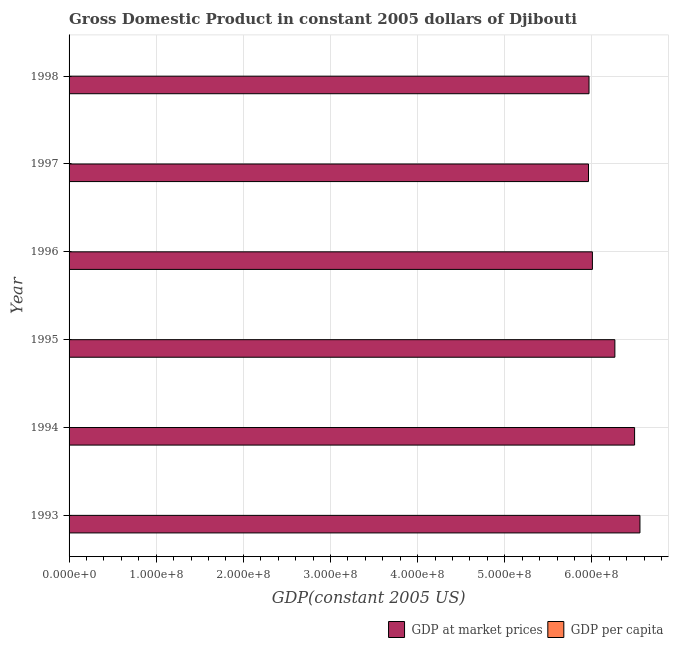How many different coloured bars are there?
Keep it short and to the point. 2. How many groups of bars are there?
Offer a very short reply. 6. Are the number of bars on each tick of the Y-axis equal?
Offer a terse response. Yes. How many bars are there on the 3rd tick from the top?
Provide a short and direct response. 2. What is the label of the 3rd group of bars from the top?
Offer a terse response. 1996. What is the gdp at market prices in 1998?
Make the answer very short. 5.97e+08. Across all years, what is the maximum gdp per capita?
Provide a succinct answer. 1024.76. Across all years, what is the minimum gdp per capita?
Give a very brief answer. 854.42. In which year was the gdp at market prices maximum?
Offer a very short reply. 1993. In which year was the gdp per capita minimum?
Give a very brief answer. 1998. What is the total gdp at market prices in the graph?
Your response must be concise. 3.72e+09. What is the difference between the gdp per capita in 1994 and that in 1997?
Provide a short and direct response. 129.22. What is the difference between the gdp at market prices in 1998 and the gdp per capita in 1994?
Your response must be concise. 5.97e+08. What is the average gdp at market prices per year?
Give a very brief answer. 6.21e+08. In the year 1995, what is the difference between the gdp per capita and gdp at market prices?
Offer a very short reply. -6.26e+08. What is the ratio of the gdp at market prices in 1994 to that in 1995?
Provide a short and direct response. 1.04. Is the gdp at market prices in 1994 less than that in 1998?
Your answer should be very brief. No. Is the difference between the gdp per capita in 1995 and 1997 greater than the difference between the gdp at market prices in 1995 and 1997?
Ensure brevity in your answer.  No. What is the difference between the highest and the second highest gdp per capita?
Your answer should be compact. 26.26. What is the difference between the highest and the lowest gdp at market prices?
Your response must be concise. 5.90e+07. What does the 2nd bar from the top in 1998 represents?
Your answer should be compact. GDP at market prices. What does the 2nd bar from the bottom in 1996 represents?
Give a very brief answer. GDP per capita. How many bars are there?
Your answer should be very brief. 12. Are all the bars in the graph horizontal?
Make the answer very short. Yes. What is the difference between two consecutive major ticks on the X-axis?
Provide a short and direct response. 1.00e+08. Does the graph contain any zero values?
Make the answer very short. No. Where does the legend appear in the graph?
Give a very brief answer. Bottom right. How many legend labels are there?
Offer a very short reply. 2. How are the legend labels stacked?
Your answer should be very brief. Horizontal. What is the title of the graph?
Provide a succinct answer. Gross Domestic Product in constant 2005 dollars of Djibouti. Does "Urban Population" appear as one of the legend labels in the graph?
Offer a very short reply. No. What is the label or title of the X-axis?
Make the answer very short. GDP(constant 2005 US). What is the GDP(constant 2005 US) in GDP at market prices in 1993?
Provide a succinct answer. 6.55e+08. What is the GDP(constant 2005 US) of GDP per capita in 1993?
Give a very brief answer. 1024.76. What is the GDP(constant 2005 US) in GDP at market prices in 1994?
Give a very brief answer. 6.49e+08. What is the GDP(constant 2005 US) of GDP per capita in 1994?
Ensure brevity in your answer.  998.5. What is the GDP(constant 2005 US) in GDP at market prices in 1995?
Keep it short and to the point. 6.26e+08. What is the GDP(constant 2005 US) in GDP per capita in 1995?
Keep it short and to the point. 947.34. What is the GDP(constant 2005 US) in GDP at market prices in 1996?
Ensure brevity in your answer.  6.00e+08. What is the GDP(constant 2005 US) of GDP per capita in 1996?
Provide a short and direct response. 891.99. What is the GDP(constant 2005 US) in GDP at market prices in 1997?
Your answer should be very brief. 5.96e+08. What is the GDP(constant 2005 US) of GDP per capita in 1997?
Ensure brevity in your answer.  869.27. What is the GDP(constant 2005 US) of GDP at market prices in 1998?
Your answer should be compact. 5.97e+08. What is the GDP(constant 2005 US) in GDP per capita in 1998?
Offer a terse response. 854.42. Across all years, what is the maximum GDP(constant 2005 US) in GDP at market prices?
Your answer should be compact. 6.55e+08. Across all years, what is the maximum GDP(constant 2005 US) of GDP per capita?
Provide a short and direct response. 1024.76. Across all years, what is the minimum GDP(constant 2005 US) in GDP at market prices?
Keep it short and to the point. 5.96e+08. Across all years, what is the minimum GDP(constant 2005 US) of GDP per capita?
Your answer should be very brief. 854.42. What is the total GDP(constant 2005 US) in GDP at market prices in the graph?
Provide a short and direct response. 3.72e+09. What is the total GDP(constant 2005 US) of GDP per capita in the graph?
Provide a succinct answer. 5586.29. What is the difference between the GDP(constant 2005 US) of GDP at market prices in 1993 and that in 1994?
Your answer should be compact. 6.14e+06. What is the difference between the GDP(constant 2005 US) in GDP per capita in 1993 and that in 1994?
Offer a terse response. 26.26. What is the difference between the GDP(constant 2005 US) of GDP at market prices in 1993 and that in 1995?
Ensure brevity in your answer.  2.88e+07. What is the difference between the GDP(constant 2005 US) of GDP per capita in 1993 and that in 1995?
Provide a short and direct response. 77.42. What is the difference between the GDP(constant 2005 US) of GDP at market prices in 1993 and that in 1996?
Your response must be concise. 5.45e+07. What is the difference between the GDP(constant 2005 US) in GDP per capita in 1993 and that in 1996?
Provide a short and direct response. 132.77. What is the difference between the GDP(constant 2005 US) in GDP at market prices in 1993 and that in 1997?
Give a very brief answer. 5.90e+07. What is the difference between the GDP(constant 2005 US) in GDP per capita in 1993 and that in 1997?
Your response must be concise. 155.48. What is the difference between the GDP(constant 2005 US) in GDP at market prices in 1993 and that in 1998?
Give a very brief answer. 5.84e+07. What is the difference between the GDP(constant 2005 US) in GDP per capita in 1993 and that in 1998?
Offer a very short reply. 170.34. What is the difference between the GDP(constant 2005 US) in GDP at market prices in 1994 and that in 1995?
Your answer should be very brief. 2.26e+07. What is the difference between the GDP(constant 2005 US) of GDP per capita in 1994 and that in 1995?
Offer a very short reply. 51.15. What is the difference between the GDP(constant 2005 US) in GDP at market prices in 1994 and that in 1996?
Your response must be concise. 4.84e+07. What is the difference between the GDP(constant 2005 US) of GDP per capita in 1994 and that in 1996?
Offer a terse response. 106.5. What is the difference between the GDP(constant 2005 US) of GDP at market prices in 1994 and that in 1997?
Give a very brief answer. 5.29e+07. What is the difference between the GDP(constant 2005 US) of GDP per capita in 1994 and that in 1997?
Offer a very short reply. 129.22. What is the difference between the GDP(constant 2005 US) of GDP at market prices in 1994 and that in 1998?
Keep it short and to the point. 5.23e+07. What is the difference between the GDP(constant 2005 US) in GDP per capita in 1994 and that in 1998?
Your answer should be compact. 144.07. What is the difference between the GDP(constant 2005 US) in GDP at market prices in 1995 and that in 1996?
Offer a very short reply. 2.58e+07. What is the difference between the GDP(constant 2005 US) in GDP per capita in 1995 and that in 1996?
Offer a terse response. 55.35. What is the difference between the GDP(constant 2005 US) in GDP at market prices in 1995 and that in 1997?
Your answer should be very brief. 3.03e+07. What is the difference between the GDP(constant 2005 US) of GDP per capita in 1995 and that in 1997?
Give a very brief answer. 78.07. What is the difference between the GDP(constant 2005 US) in GDP at market prices in 1995 and that in 1998?
Ensure brevity in your answer.  2.97e+07. What is the difference between the GDP(constant 2005 US) in GDP per capita in 1995 and that in 1998?
Offer a very short reply. 92.92. What is the difference between the GDP(constant 2005 US) in GDP at market prices in 1996 and that in 1997?
Offer a very short reply. 4.48e+06. What is the difference between the GDP(constant 2005 US) of GDP per capita in 1996 and that in 1997?
Your response must be concise. 22.72. What is the difference between the GDP(constant 2005 US) of GDP at market prices in 1996 and that in 1998?
Your answer should be compact. 3.89e+06. What is the difference between the GDP(constant 2005 US) of GDP per capita in 1996 and that in 1998?
Ensure brevity in your answer.  37.57. What is the difference between the GDP(constant 2005 US) in GDP at market prices in 1997 and that in 1998?
Provide a succinct answer. -5.92e+05. What is the difference between the GDP(constant 2005 US) in GDP per capita in 1997 and that in 1998?
Keep it short and to the point. 14.85. What is the difference between the GDP(constant 2005 US) of GDP at market prices in 1993 and the GDP(constant 2005 US) of GDP per capita in 1994?
Your answer should be very brief. 6.55e+08. What is the difference between the GDP(constant 2005 US) of GDP at market prices in 1993 and the GDP(constant 2005 US) of GDP per capita in 1995?
Provide a succinct answer. 6.55e+08. What is the difference between the GDP(constant 2005 US) of GDP at market prices in 1993 and the GDP(constant 2005 US) of GDP per capita in 1996?
Your response must be concise. 6.55e+08. What is the difference between the GDP(constant 2005 US) of GDP at market prices in 1993 and the GDP(constant 2005 US) of GDP per capita in 1997?
Your response must be concise. 6.55e+08. What is the difference between the GDP(constant 2005 US) in GDP at market prices in 1993 and the GDP(constant 2005 US) in GDP per capita in 1998?
Your answer should be compact. 6.55e+08. What is the difference between the GDP(constant 2005 US) in GDP at market prices in 1994 and the GDP(constant 2005 US) in GDP per capita in 1995?
Give a very brief answer. 6.49e+08. What is the difference between the GDP(constant 2005 US) in GDP at market prices in 1994 and the GDP(constant 2005 US) in GDP per capita in 1996?
Keep it short and to the point. 6.49e+08. What is the difference between the GDP(constant 2005 US) in GDP at market prices in 1994 and the GDP(constant 2005 US) in GDP per capita in 1997?
Offer a very short reply. 6.49e+08. What is the difference between the GDP(constant 2005 US) in GDP at market prices in 1994 and the GDP(constant 2005 US) in GDP per capita in 1998?
Make the answer very short. 6.49e+08. What is the difference between the GDP(constant 2005 US) of GDP at market prices in 1995 and the GDP(constant 2005 US) of GDP per capita in 1996?
Provide a short and direct response. 6.26e+08. What is the difference between the GDP(constant 2005 US) in GDP at market prices in 1995 and the GDP(constant 2005 US) in GDP per capita in 1997?
Give a very brief answer. 6.26e+08. What is the difference between the GDP(constant 2005 US) in GDP at market prices in 1995 and the GDP(constant 2005 US) in GDP per capita in 1998?
Offer a very short reply. 6.26e+08. What is the difference between the GDP(constant 2005 US) of GDP at market prices in 1996 and the GDP(constant 2005 US) of GDP per capita in 1997?
Give a very brief answer. 6.00e+08. What is the difference between the GDP(constant 2005 US) in GDP at market prices in 1996 and the GDP(constant 2005 US) in GDP per capita in 1998?
Give a very brief answer. 6.00e+08. What is the difference between the GDP(constant 2005 US) in GDP at market prices in 1997 and the GDP(constant 2005 US) in GDP per capita in 1998?
Offer a terse response. 5.96e+08. What is the average GDP(constant 2005 US) in GDP at market prices per year?
Offer a terse response. 6.21e+08. What is the average GDP(constant 2005 US) of GDP per capita per year?
Provide a short and direct response. 931.05. In the year 1993, what is the difference between the GDP(constant 2005 US) in GDP at market prices and GDP(constant 2005 US) in GDP per capita?
Provide a short and direct response. 6.55e+08. In the year 1994, what is the difference between the GDP(constant 2005 US) of GDP at market prices and GDP(constant 2005 US) of GDP per capita?
Ensure brevity in your answer.  6.49e+08. In the year 1995, what is the difference between the GDP(constant 2005 US) of GDP at market prices and GDP(constant 2005 US) of GDP per capita?
Your answer should be very brief. 6.26e+08. In the year 1996, what is the difference between the GDP(constant 2005 US) in GDP at market prices and GDP(constant 2005 US) in GDP per capita?
Provide a short and direct response. 6.00e+08. In the year 1997, what is the difference between the GDP(constant 2005 US) in GDP at market prices and GDP(constant 2005 US) in GDP per capita?
Offer a very short reply. 5.96e+08. In the year 1998, what is the difference between the GDP(constant 2005 US) of GDP at market prices and GDP(constant 2005 US) of GDP per capita?
Provide a succinct answer. 5.97e+08. What is the ratio of the GDP(constant 2005 US) in GDP at market prices in 1993 to that in 1994?
Offer a terse response. 1.01. What is the ratio of the GDP(constant 2005 US) in GDP per capita in 1993 to that in 1994?
Keep it short and to the point. 1.03. What is the ratio of the GDP(constant 2005 US) in GDP at market prices in 1993 to that in 1995?
Make the answer very short. 1.05. What is the ratio of the GDP(constant 2005 US) in GDP per capita in 1993 to that in 1995?
Give a very brief answer. 1.08. What is the ratio of the GDP(constant 2005 US) in GDP at market prices in 1993 to that in 1996?
Your response must be concise. 1.09. What is the ratio of the GDP(constant 2005 US) in GDP per capita in 1993 to that in 1996?
Provide a succinct answer. 1.15. What is the ratio of the GDP(constant 2005 US) of GDP at market prices in 1993 to that in 1997?
Ensure brevity in your answer.  1.1. What is the ratio of the GDP(constant 2005 US) in GDP per capita in 1993 to that in 1997?
Give a very brief answer. 1.18. What is the ratio of the GDP(constant 2005 US) in GDP at market prices in 1993 to that in 1998?
Make the answer very short. 1.1. What is the ratio of the GDP(constant 2005 US) of GDP per capita in 1993 to that in 1998?
Your answer should be very brief. 1.2. What is the ratio of the GDP(constant 2005 US) in GDP at market prices in 1994 to that in 1995?
Your answer should be compact. 1.04. What is the ratio of the GDP(constant 2005 US) of GDP per capita in 1994 to that in 1995?
Offer a terse response. 1.05. What is the ratio of the GDP(constant 2005 US) in GDP at market prices in 1994 to that in 1996?
Your response must be concise. 1.08. What is the ratio of the GDP(constant 2005 US) of GDP per capita in 1994 to that in 1996?
Keep it short and to the point. 1.12. What is the ratio of the GDP(constant 2005 US) in GDP at market prices in 1994 to that in 1997?
Ensure brevity in your answer.  1.09. What is the ratio of the GDP(constant 2005 US) of GDP per capita in 1994 to that in 1997?
Provide a succinct answer. 1.15. What is the ratio of the GDP(constant 2005 US) in GDP at market prices in 1994 to that in 1998?
Make the answer very short. 1.09. What is the ratio of the GDP(constant 2005 US) in GDP per capita in 1994 to that in 1998?
Provide a succinct answer. 1.17. What is the ratio of the GDP(constant 2005 US) of GDP at market prices in 1995 to that in 1996?
Your answer should be compact. 1.04. What is the ratio of the GDP(constant 2005 US) in GDP per capita in 1995 to that in 1996?
Offer a very short reply. 1.06. What is the ratio of the GDP(constant 2005 US) of GDP at market prices in 1995 to that in 1997?
Make the answer very short. 1.05. What is the ratio of the GDP(constant 2005 US) in GDP per capita in 1995 to that in 1997?
Your response must be concise. 1.09. What is the ratio of the GDP(constant 2005 US) of GDP at market prices in 1995 to that in 1998?
Offer a very short reply. 1.05. What is the ratio of the GDP(constant 2005 US) in GDP per capita in 1995 to that in 1998?
Your answer should be very brief. 1.11. What is the ratio of the GDP(constant 2005 US) in GDP at market prices in 1996 to that in 1997?
Your answer should be very brief. 1.01. What is the ratio of the GDP(constant 2005 US) in GDP per capita in 1996 to that in 1997?
Provide a succinct answer. 1.03. What is the ratio of the GDP(constant 2005 US) in GDP per capita in 1996 to that in 1998?
Provide a short and direct response. 1.04. What is the ratio of the GDP(constant 2005 US) of GDP at market prices in 1997 to that in 1998?
Keep it short and to the point. 1. What is the ratio of the GDP(constant 2005 US) in GDP per capita in 1997 to that in 1998?
Give a very brief answer. 1.02. What is the difference between the highest and the second highest GDP(constant 2005 US) in GDP at market prices?
Offer a terse response. 6.14e+06. What is the difference between the highest and the second highest GDP(constant 2005 US) in GDP per capita?
Provide a short and direct response. 26.26. What is the difference between the highest and the lowest GDP(constant 2005 US) of GDP at market prices?
Your answer should be very brief. 5.90e+07. What is the difference between the highest and the lowest GDP(constant 2005 US) in GDP per capita?
Your answer should be very brief. 170.34. 